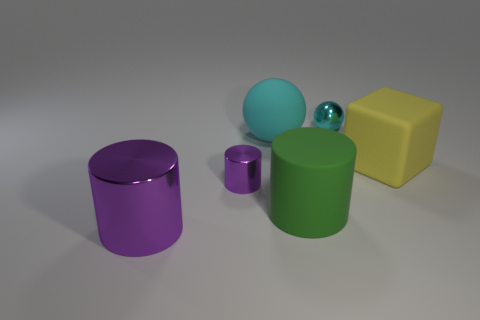Add 1 tiny metal spheres. How many objects exist? 7 Subtract all small purple cylinders. How many cylinders are left? 2 Subtract all balls. How many objects are left? 4 Subtract all purple cylinders. How many cylinders are left? 1 Subtract 1 yellow blocks. How many objects are left? 5 Subtract 1 spheres. How many spheres are left? 1 Subtract all gray balls. Subtract all purple cylinders. How many balls are left? 2 Subtract all green cylinders. How many brown balls are left? 0 Subtract all purple metal cylinders. Subtract all big cubes. How many objects are left? 3 Add 5 small cyan metal things. How many small cyan metal things are left? 6 